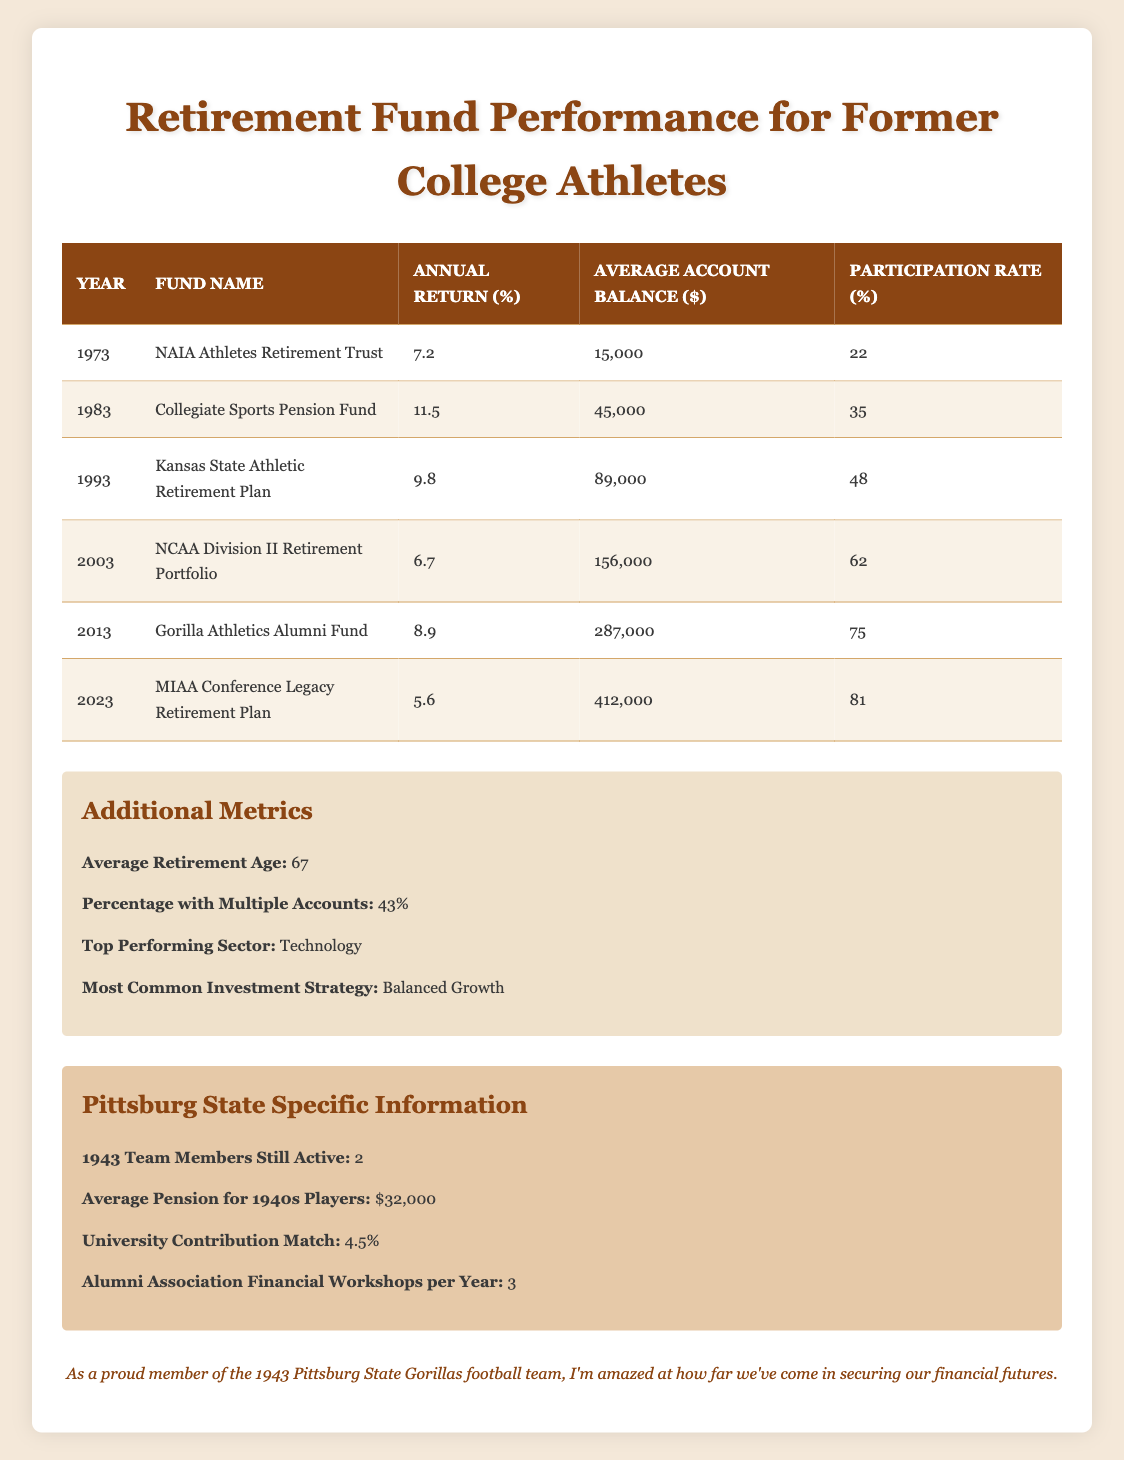What was the annual return of the NCAA Division II Retirement Portfolio in 2003? From the table, locate the row for the year 2003 under the "Annual Return (%)" column. It shows an annual return of 6.7 for the NCAA Division II Retirement Portfolio.
Answer: 6.7 What is the average account balance for the Gorilla Athletics Alumni Fund in 2013? Check the row for the year 2013 under the "Average Account Balance ($)" column. It shows an average account balance of 287,000 for the Gorilla Athletics Alumni Fund.
Answer: 287000 Was the participation rate higher in 2023 compared to 2003? Compare the "Participation Rate (%)" values for the years 2023 and 2003. The rate for 2023 is 81%, while for 2003 it is 62%. Thus, 81% is higher than 62%.
Answer: Yes What is the total average account balance for all funds from 1973 to 2023? Sum the average account balances from all provided years: 15,000 + 45,000 + 89,000 + 156,000 + 287,000 + 412,000 equals 1,004,000. Then, divide this sum by the number of funds (6) to find the average: 1,004,000 / 6 equals approximately 167,333.33.
Answer: 167333.33 In which year did the Collegiate Sports Pension Fund show the highest annual return? The table shows the annual returns for each fund over the years, where Collegiate Sports Pension Fund in 1983 had an annual return of 11.5, which is the highest return listed in the table.
Answer: 1983 Is the average retirement age for former collegiate athletes higher or lower than 65? From the additional metrics, the average retirement age is given as 67, which is higher than 65.
Answer: Higher What percentage of former athletes have multiple retirement accounts, and how does it compare to the participation rate in 2013? The table indicates that 43% of former athletes have multiple retirement accounts. For the year 2013, the participation rate was 75%. Thus, 43% is lower than 75%.
Answer: 43% is lower Which retirement fund had the lowest participation rate, and what was that rate? Looking over the participation rates in the table, the NAIA Athletes Retirement Trust in 1973 has the lowest rate at 22%.
Answer: 22 Calculate the difference in average account balance between the Kansas State Athletic Retirement Plan in 1993 and the MIAA Conference Legacy Retirement Plan in 2023. The average account balance for Kansas State Athletic Retirement Plan in 1993 is 89,000, and for MIAA Conference Legacy Retirement Plan in 2023, it is 412,000. The difference is 412,000 - 89,000, which equals 323,000.
Answer: 323000 